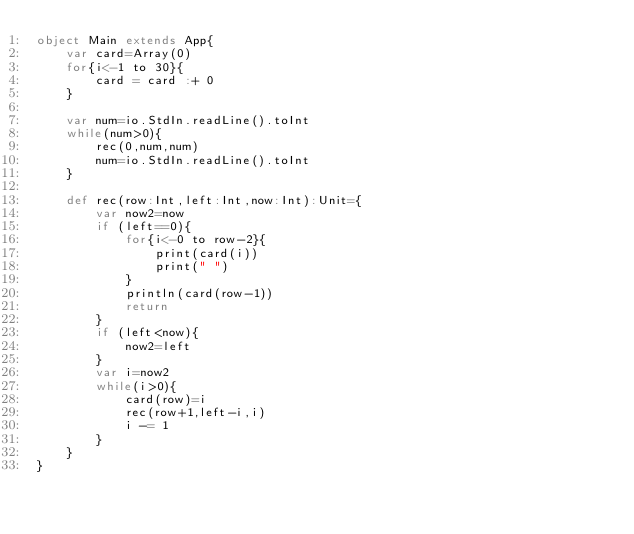Convert code to text. <code><loc_0><loc_0><loc_500><loc_500><_Scala_>object Main extends App{
    var card=Array(0)
    for{i<-1 to 30}{
        card = card :+ 0
    }

    var num=io.StdIn.readLine().toInt
    while(num>0){
        rec(0,num,num)
        num=io.StdIn.readLine().toInt
    }
    
    def rec(row:Int,left:Int,now:Int):Unit={
        var now2=now
        if (left==0){
            for{i<-0 to row-2}{
                print(card(i))
                print(" ")
            }
            println(card(row-1))
            return
        }
        if (left<now){
            now2=left
        }
        var i=now2
        while(i>0){
            card(row)=i
            rec(row+1,left-i,i)
            i -= 1
        }
    }
}

</code> 